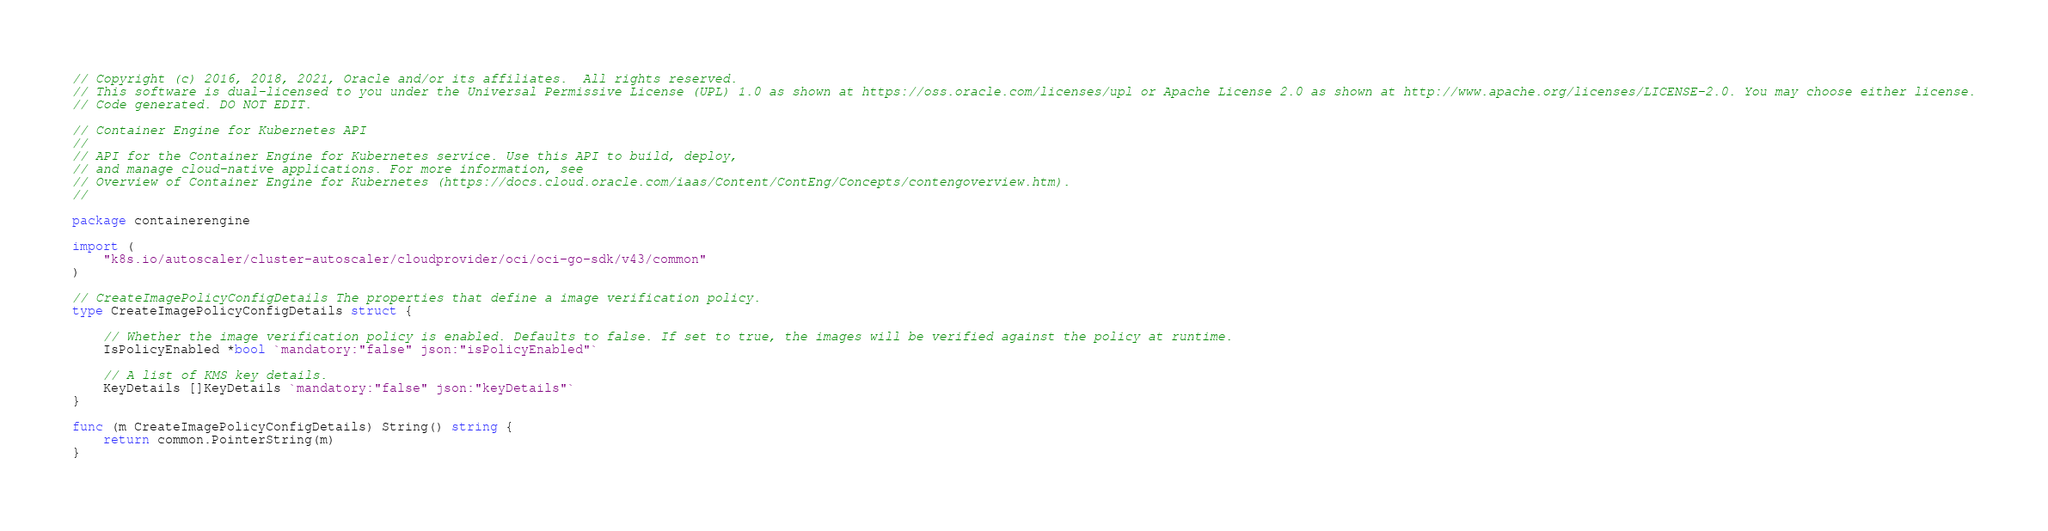<code> <loc_0><loc_0><loc_500><loc_500><_Go_>// Copyright (c) 2016, 2018, 2021, Oracle and/or its affiliates.  All rights reserved.
// This software is dual-licensed to you under the Universal Permissive License (UPL) 1.0 as shown at https://oss.oracle.com/licenses/upl or Apache License 2.0 as shown at http://www.apache.org/licenses/LICENSE-2.0. You may choose either license.
// Code generated. DO NOT EDIT.

// Container Engine for Kubernetes API
//
// API for the Container Engine for Kubernetes service. Use this API to build, deploy,
// and manage cloud-native applications. For more information, see
// Overview of Container Engine for Kubernetes (https://docs.cloud.oracle.com/iaas/Content/ContEng/Concepts/contengoverview.htm).
//

package containerengine

import (
	"k8s.io/autoscaler/cluster-autoscaler/cloudprovider/oci/oci-go-sdk/v43/common"
)

// CreateImagePolicyConfigDetails The properties that define a image verification policy.
type CreateImagePolicyConfigDetails struct {

	// Whether the image verification policy is enabled. Defaults to false. If set to true, the images will be verified against the policy at runtime.
	IsPolicyEnabled *bool `mandatory:"false" json:"isPolicyEnabled"`

	// A list of KMS key details.
	KeyDetails []KeyDetails `mandatory:"false" json:"keyDetails"`
}

func (m CreateImagePolicyConfigDetails) String() string {
	return common.PointerString(m)
}
</code> 